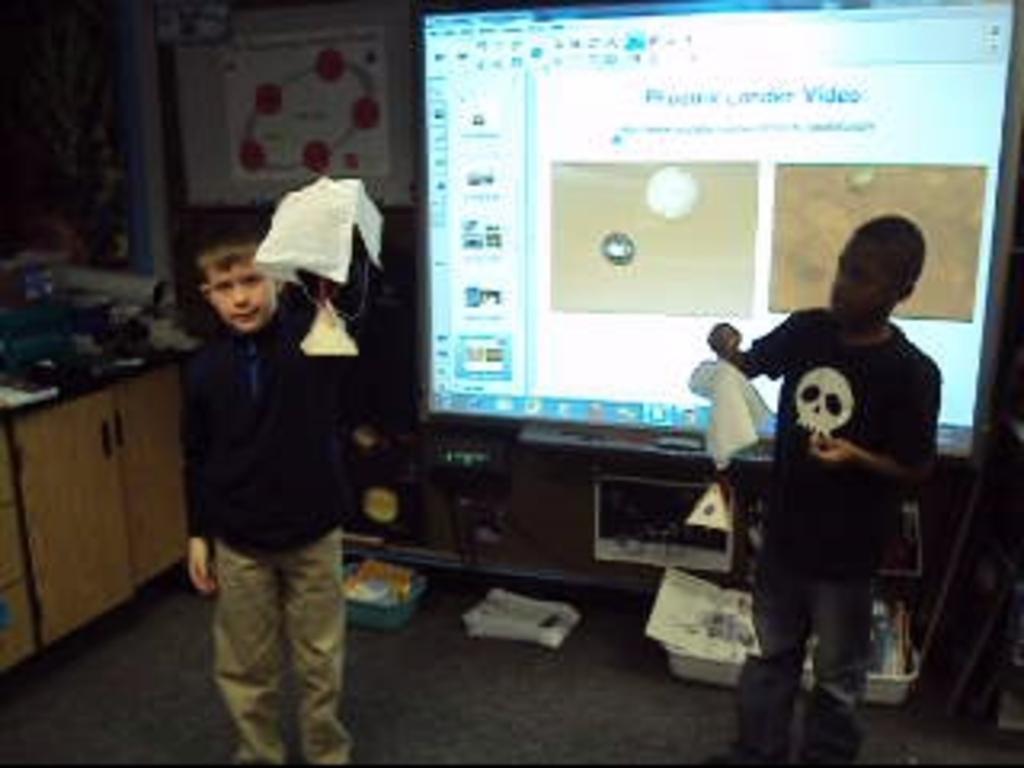In one or two sentences, can you explain what this image depicts? Here we can see two persons they were holding napkins. Back of them we can see the screen. And on the left side we can see the cupboard. And they were surrounded with few objects. 